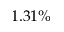<formula> <loc_0><loc_0><loc_500><loc_500>1 . 3 1 \%</formula> 